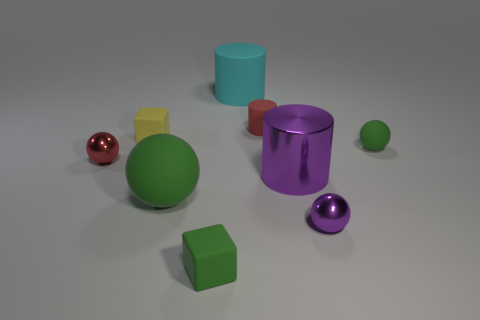Are there any other things that have the same size as the purple ball? From the perspective provided in the image, it is difficult to ascertain the exact dimensions of all objects relative to one another. However, from a visual estimate, none of the other objects appear to match the size of the purple ball exactly. Each object varies in size and shape, contributing to a diverse array of forms within the scene. 